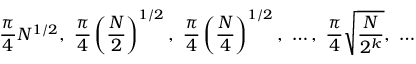Convert formula to latex. <formula><loc_0><loc_0><loc_500><loc_500>{ \frac { \pi } { 4 } } { N } ^ { 1 / 2 } , \ { \frac { \pi } { 4 } } \left ( { \frac { N } { 2 } } \right ) ^ { 1 / 2 } , \ { \frac { \pi } { 4 } } \left ( { \frac { N } { 4 } } \right ) ^ { 1 / 2 } , \ \dots , \ { \frac { \pi } { 4 } } { \sqrt { \frac { N } { 2 ^ { k } } } } , \ \dots</formula> 